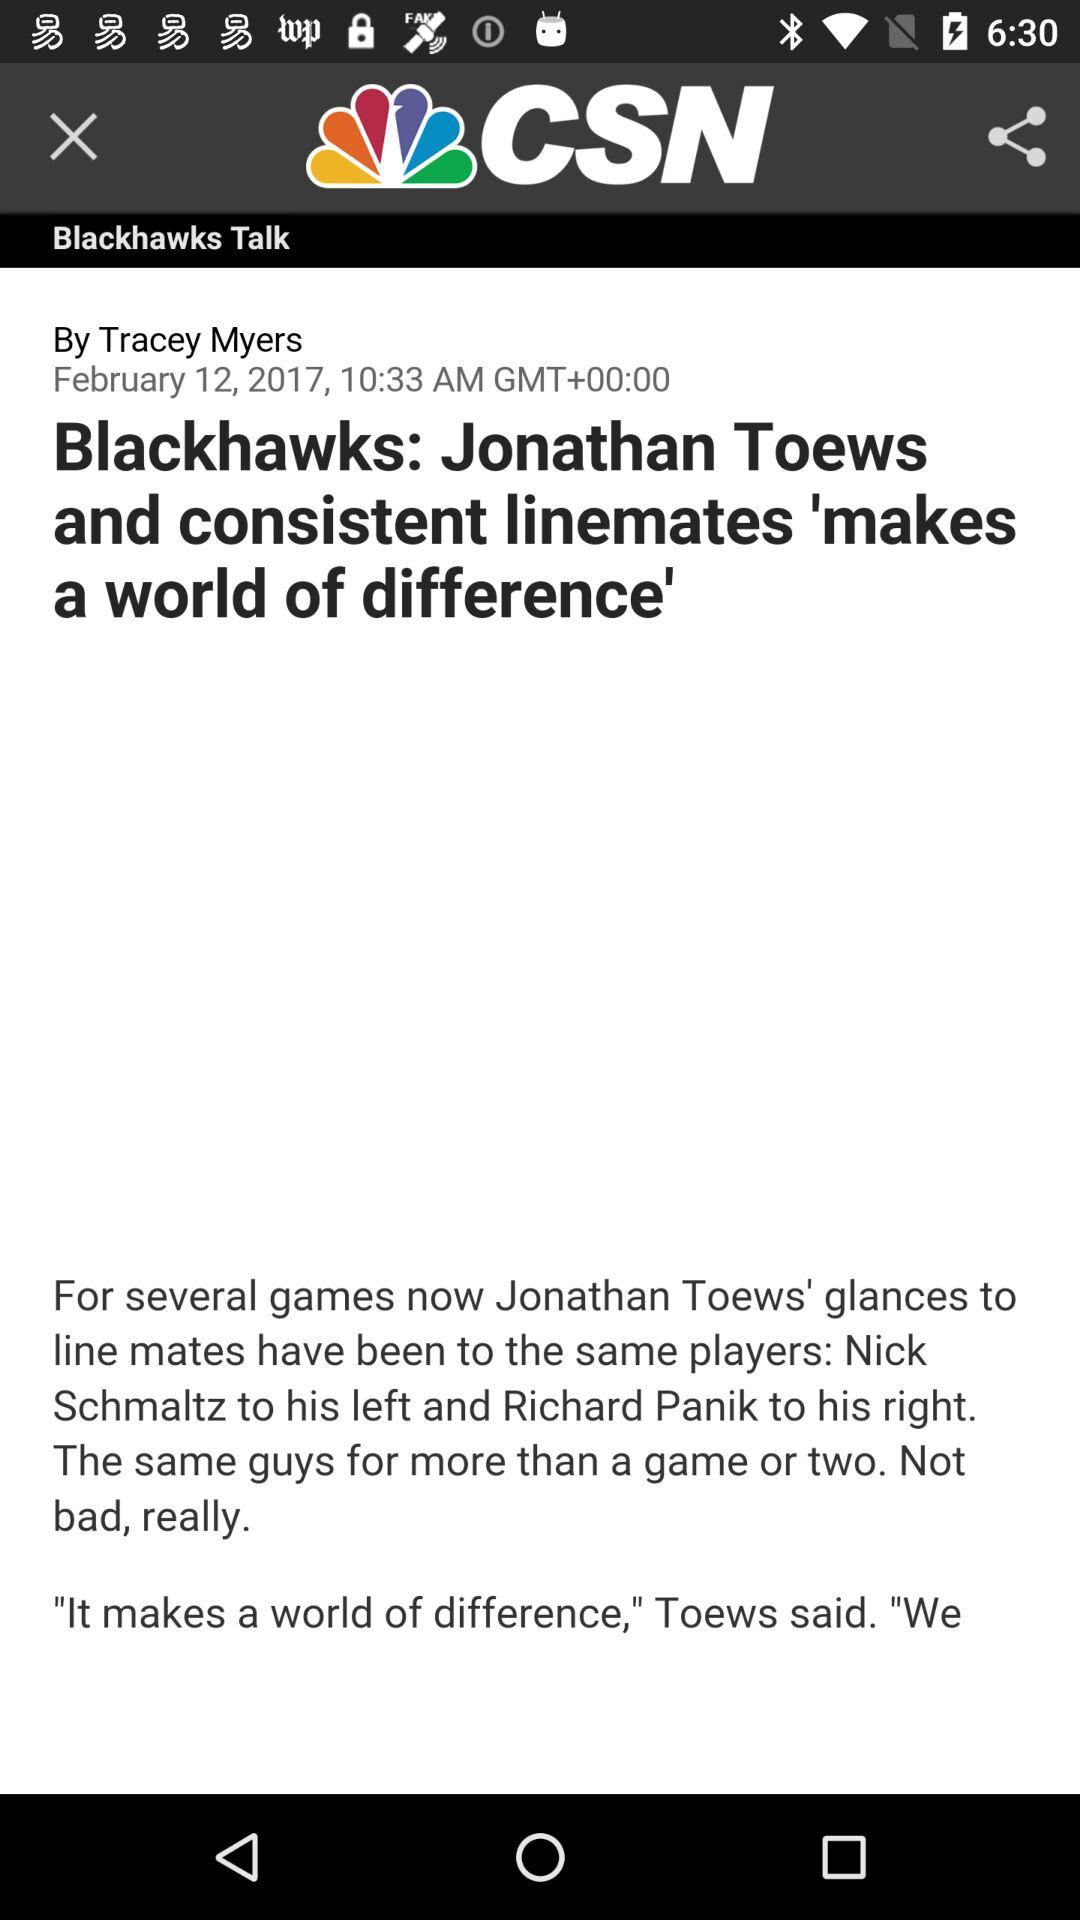On what date was this post uploaded? This post was uploaded on February 12, 2017. 